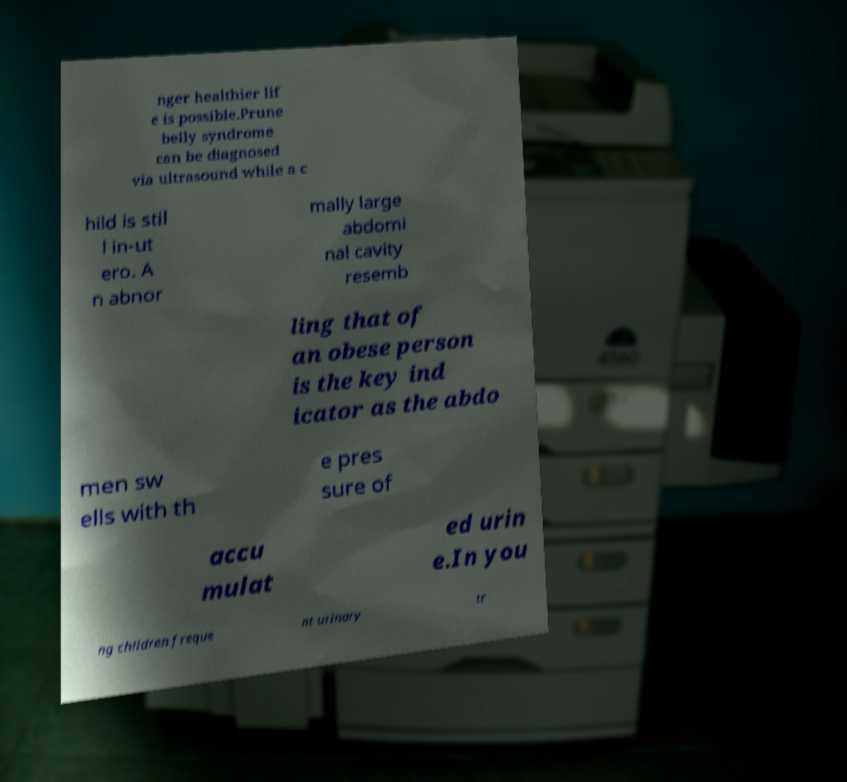Please read and relay the text visible in this image. What does it say? nger healthier lif e is possible.Prune belly syndrome can be diagnosed via ultrasound while a c hild is stil l in-ut ero. A n abnor mally large abdomi nal cavity resemb ling that of an obese person is the key ind icator as the abdo men sw ells with th e pres sure of accu mulat ed urin e.In you ng children freque nt urinary tr 